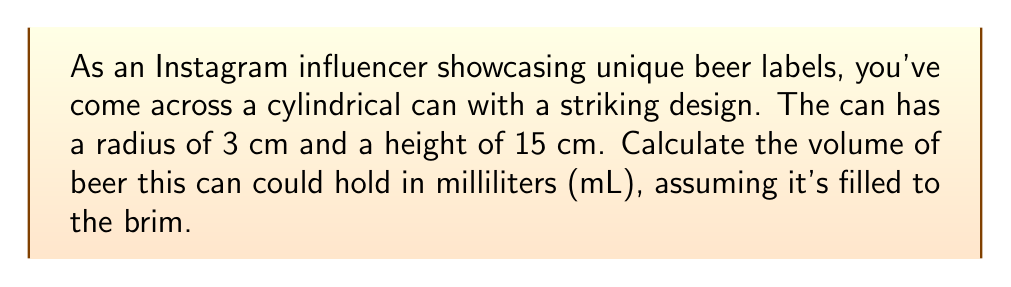Give your solution to this math problem. To solve this problem, we'll follow these steps:

1. Recall the formula for the volume of a cylinder:
   $$V = \pi r^2 h$$
   where $V$ is volume, $r$ is radius, and $h$ is height.

2. Substitute the given values:
   $r = 3$ cm
   $h = 15$ cm

3. Calculate the volume:
   $$V = \pi (3\text{ cm})^2 (15\text{ cm})$$
   $$V = \pi (9\text{ cm}^2) (15\text{ cm})$$
   $$V = 135\pi\text{ cm}^3$$

4. Evaluate $\pi$ to 2 decimal places:
   $$V \approx 135 \times 3.14\text{ cm}^3$$
   $$V \approx 423.9\text{ cm}^3$$

5. Convert cubic centimeters to milliliters:
   1 cm³ = 1 mL, so the volume in mL is the same numerical value.

   $$V \approx 423.9\text{ mL}$$

6. Round to the nearest mL:
   $$V \approx 424\text{ mL}$$
Answer: 424 mL 